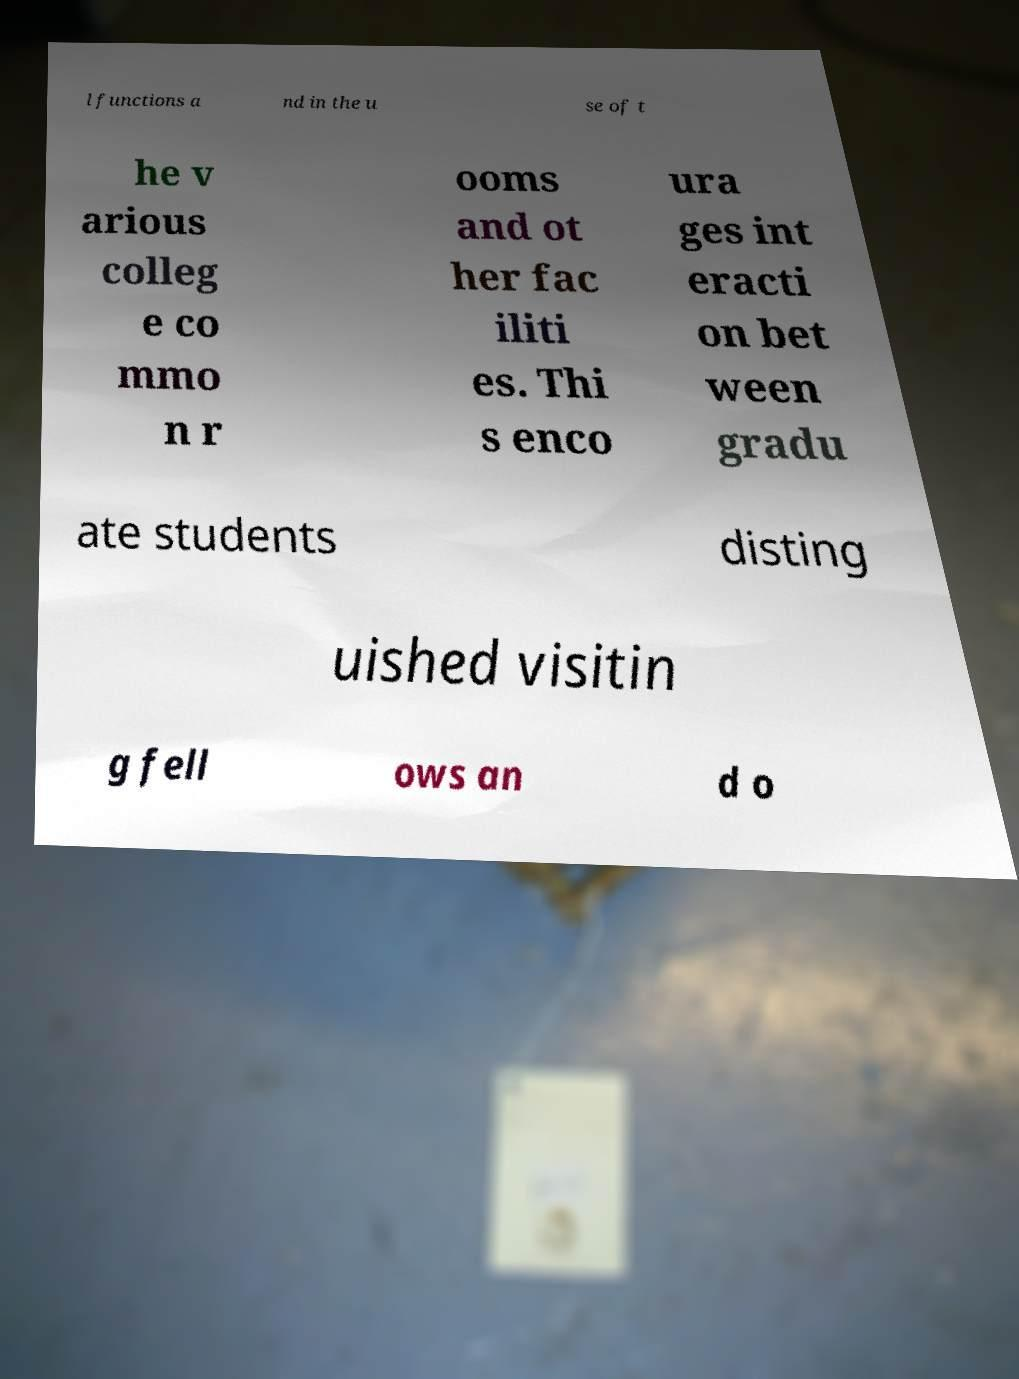I need the written content from this picture converted into text. Can you do that? l functions a nd in the u se of t he v arious colleg e co mmo n r ooms and ot her fac iliti es. Thi s enco ura ges int eracti on bet ween gradu ate students disting uished visitin g fell ows an d o 